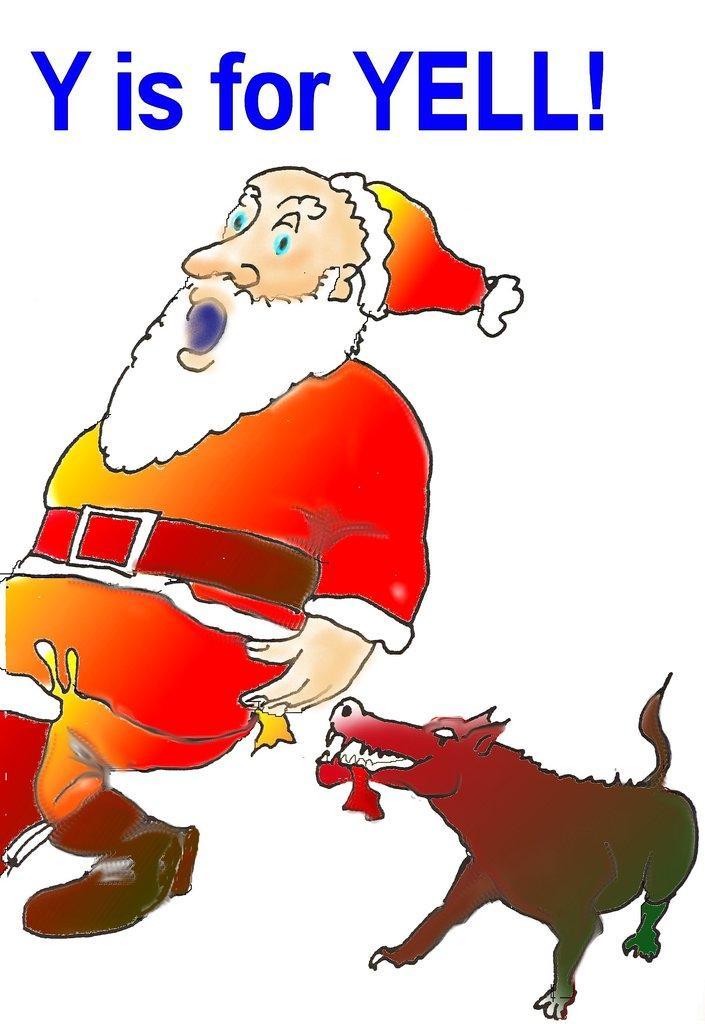In one or two sentences, can you explain what this image depicts? In this picture we can see animated photo of the Santa Claus, wearing red dress. Behind there is a dog and above we can see "Y is for Yell" is written. 